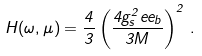Convert formula to latex. <formula><loc_0><loc_0><loc_500><loc_500>H ( \omega , \mu ) = \frac { 4 } { 3 } \left ( \frac { 4 g _ { s } ^ { 2 } e e _ { b } } { 3 M } \right ) ^ { 2 } \, .</formula> 